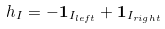<formula> <loc_0><loc_0><loc_500><loc_500>h _ { I } = - \mathbf 1 _ { I _ { l e f t } } + \mathbf 1 _ { I _ { r i g h t } }</formula> 